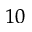Convert formula to latex. <formula><loc_0><loc_0><loc_500><loc_500>^ { 1 0 }</formula> 